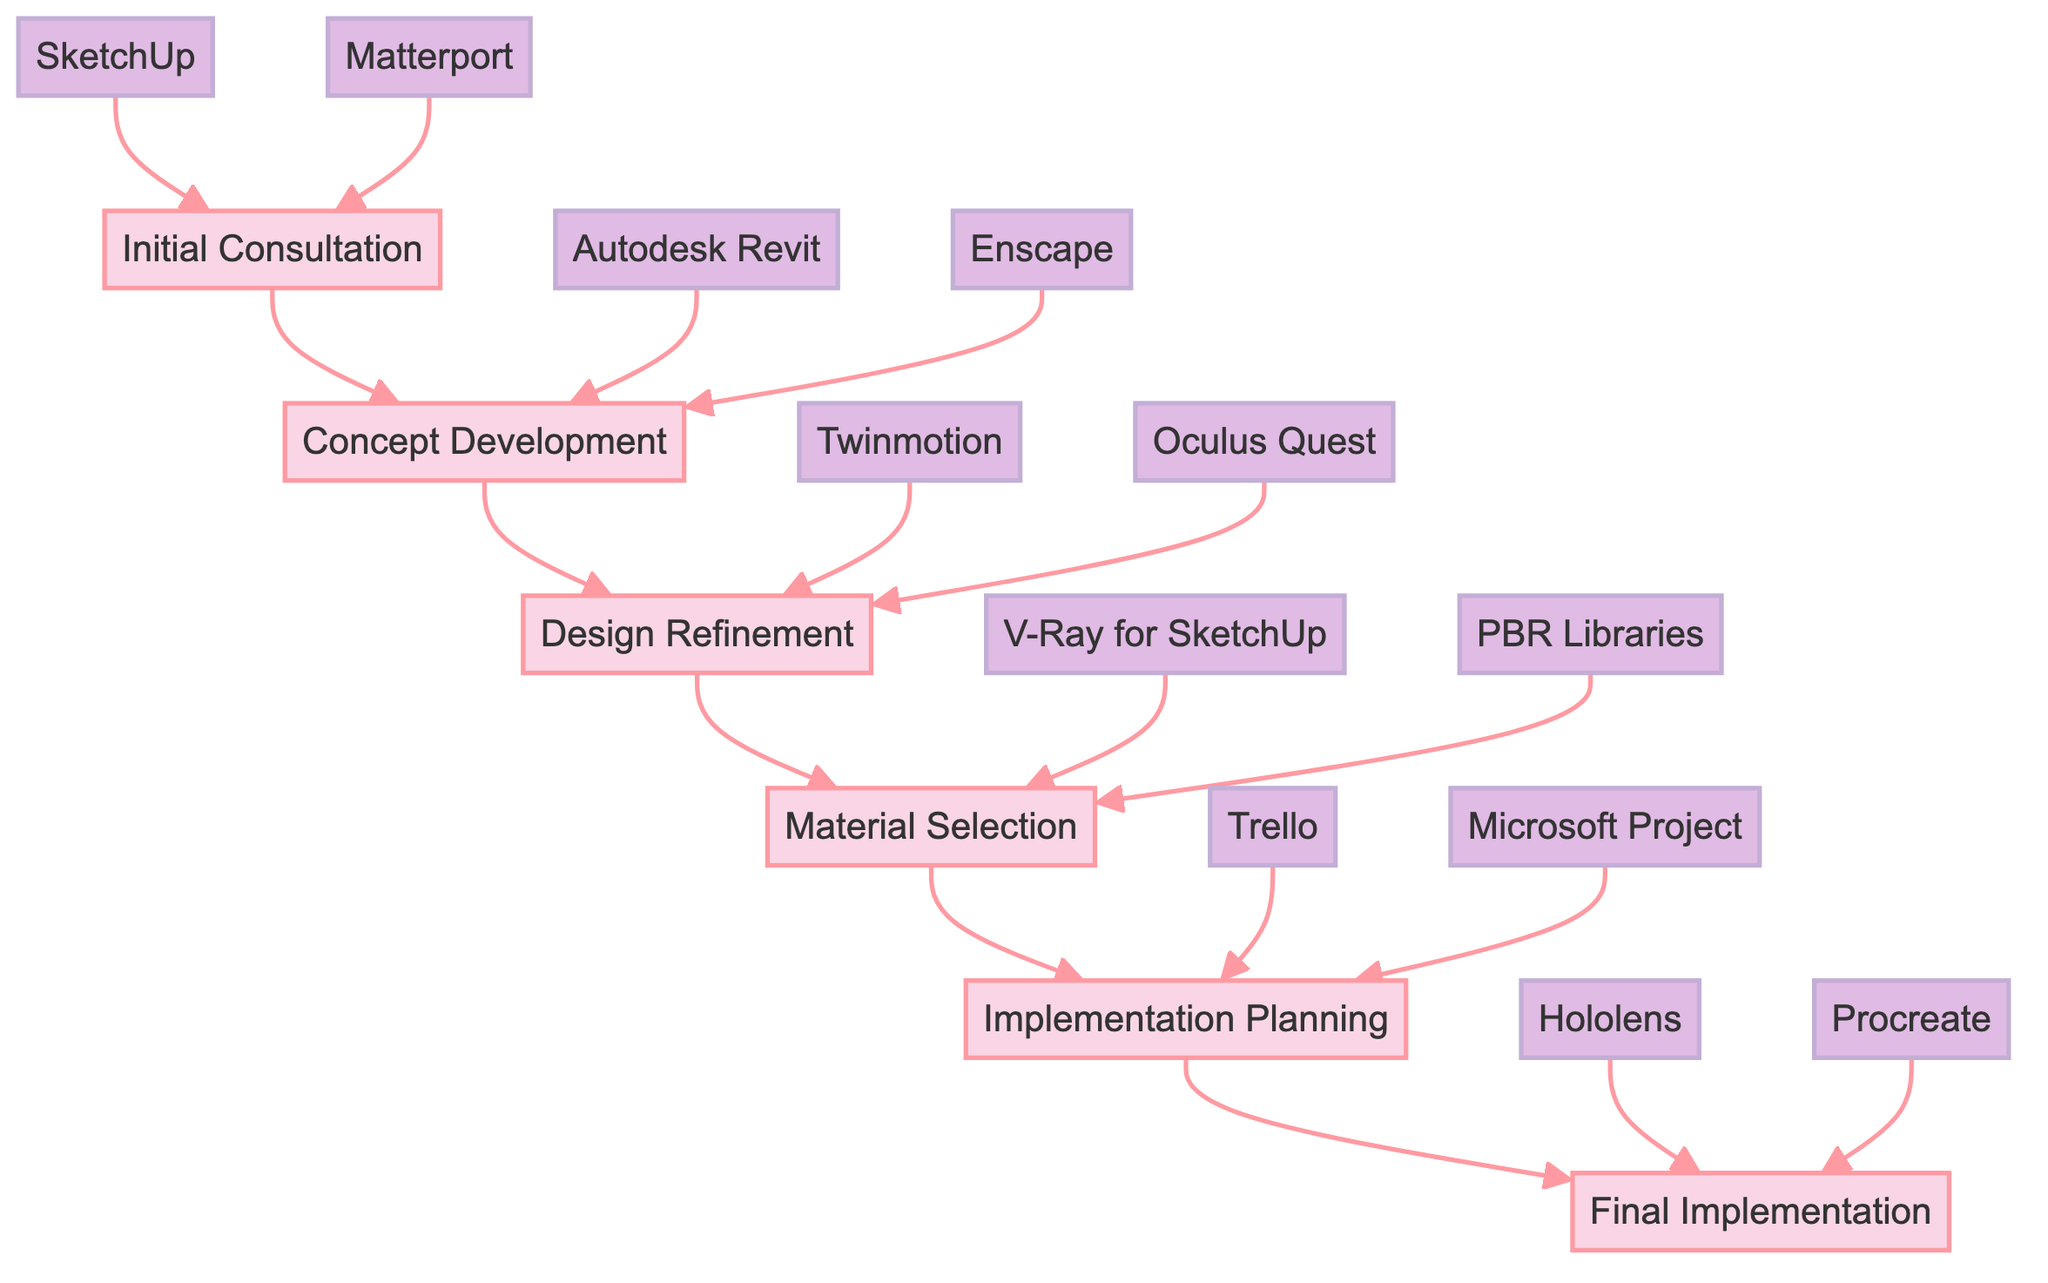What is the first stage in the timeline? The diagram indicates the first stage in the timeline is labeled as "Initial Consultation".
Answer: Initial Consultation How many stages are in the diagram? By counting each labeled stage from the diagram, there are a total of six stages listed.
Answer: 6 Which tools are used during the Design Refinement stage? The tools associated with the Design Refinement stage, as shown in the diagram, are "Twinmotion" and "Oculus Quest".
Answer: Twinmotion, Oculus Quest What key action occurs during the Material Selection stage? The diagram specifies that a key action during the Material Selection stage is "VR visualization of materials and finishes".
Answer: VR visualization of materials and finishes At which stage does the final client walkthrough occur? According to the diagram, the final client walkthrough takes place in the "Final Implementation" stage.
Answer: Final Implementation Which stage immediately follows Concept Development? The diagram clearly shows that the stage that follows Concept Development is "Design Refinement".
Answer: Design Refinement What is one of the tools used in Initial Consultation? The diagram lists "SketchUp" as one of the tools utilized in the Initial Consultation stage.
Answer: SketchUp What is created during the Implementation Planning stage? The diagram highlights that during the Implementation Planning stage, a "comprehensive project plan" is created.
Answer: comprehensive project plan How does the implementation process begin? The diagram states that the implementation process begins with "On-site VR-assisted setup".
Answer: On-site VR-assisted setup 